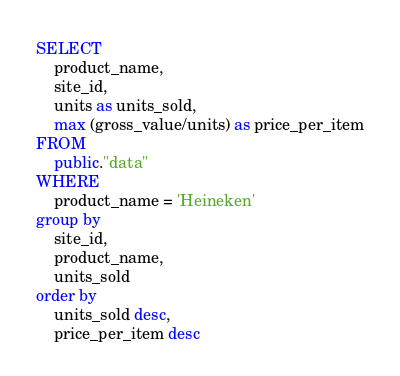<code> <loc_0><loc_0><loc_500><loc_500><_SQL_>SELECT 
	product_name,
	site_id,
	units as units_sold,
	max (gross_value/units) as price_per_item
FROM 
	public."data"
WHERE 
	product_name = 'Heineken'
group by 
	site_id, 
	product_name, 
	units_sold
order by 
	units_sold desc,
	price_per_item desc
</code> 